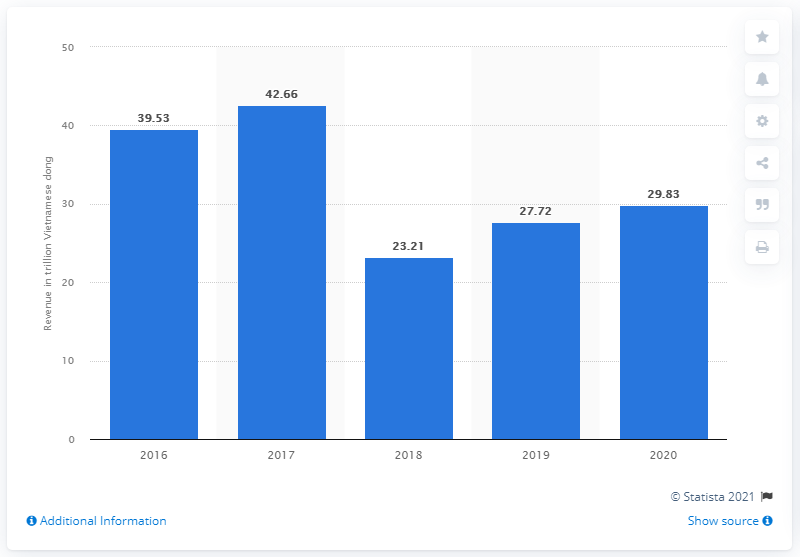Identify some key points in this picture. FPT Corporation's consolidated revenue in 2020 was VND 29,830,000,000. 